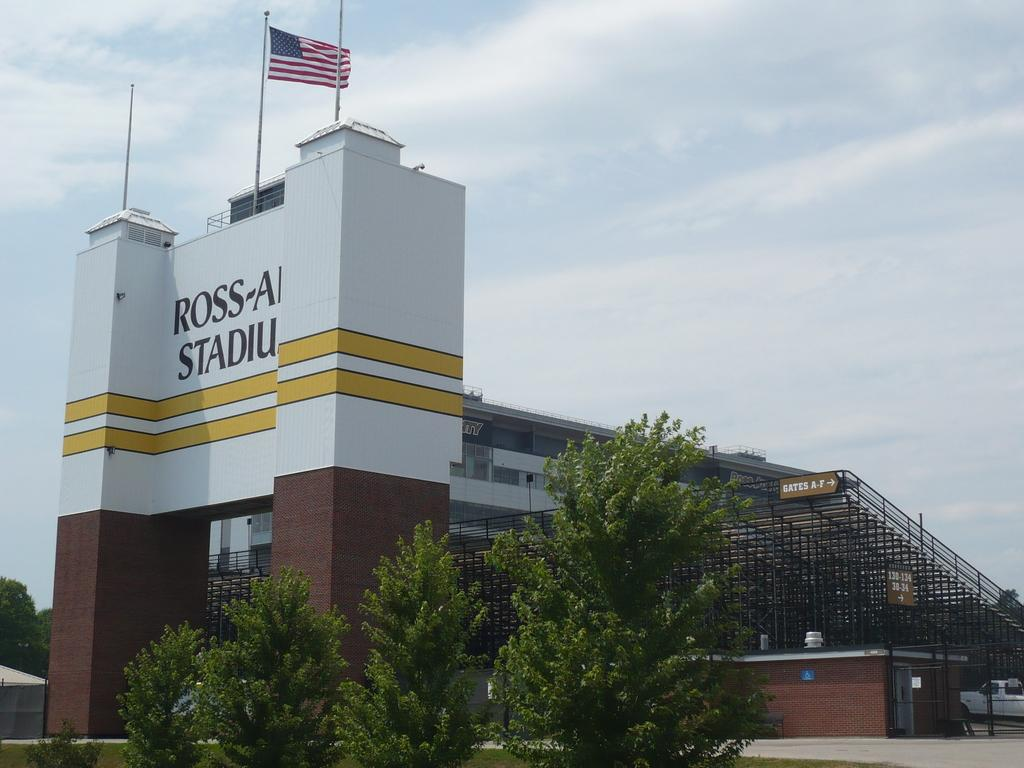<image>
Summarize the visual content of the image. Gates A-F are to the right of the main entrance to a stadium. 